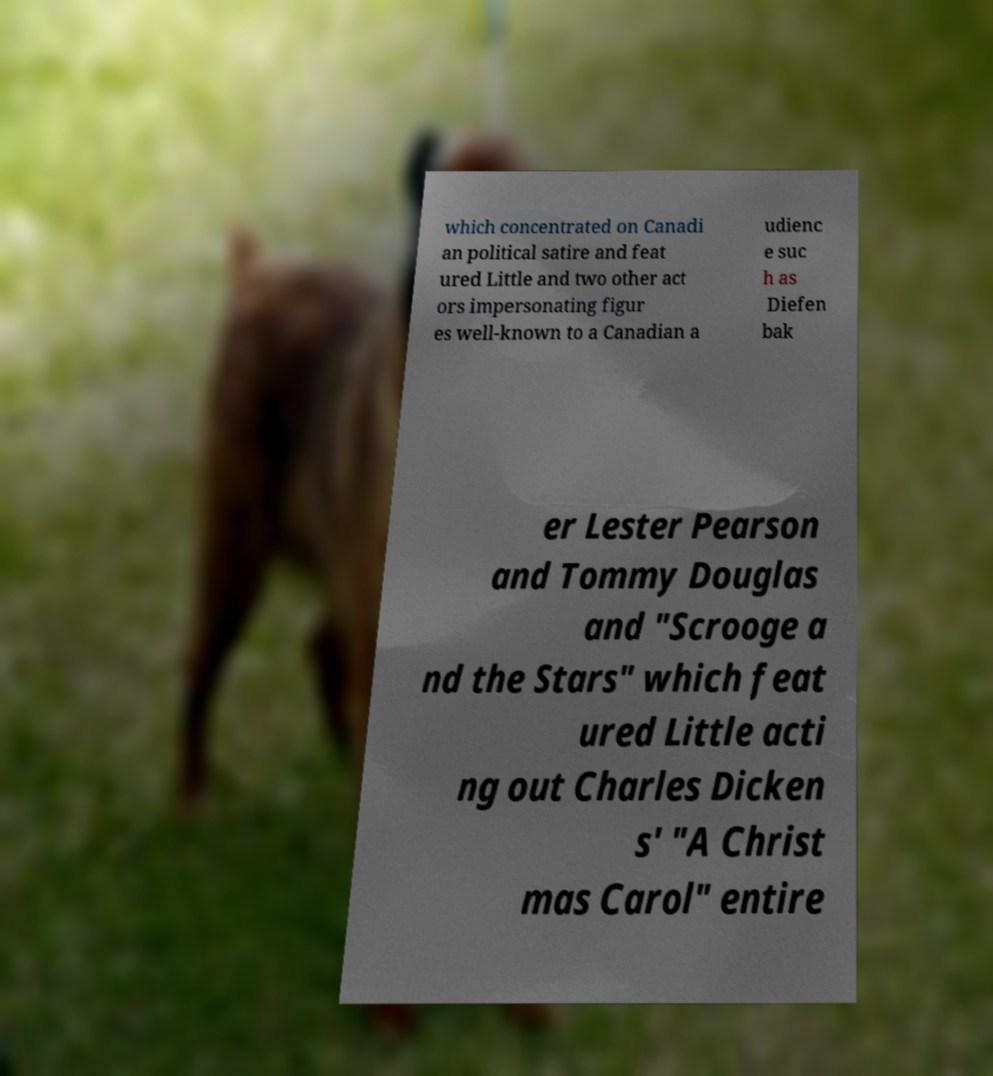What messages or text are displayed in this image? I need them in a readable, typed format. which concentrated on Canadi an political satire and feat ured Little and two other act ors impersonating figur es well-known to a Canadian a udienc e suc h as Diefen bak er Lester Pearson and Tommy Douglas and "Scrooge a nd the Stars" which feat ured Little acti ng out Charles Dicken s' "A Christ mas Carol" entire 